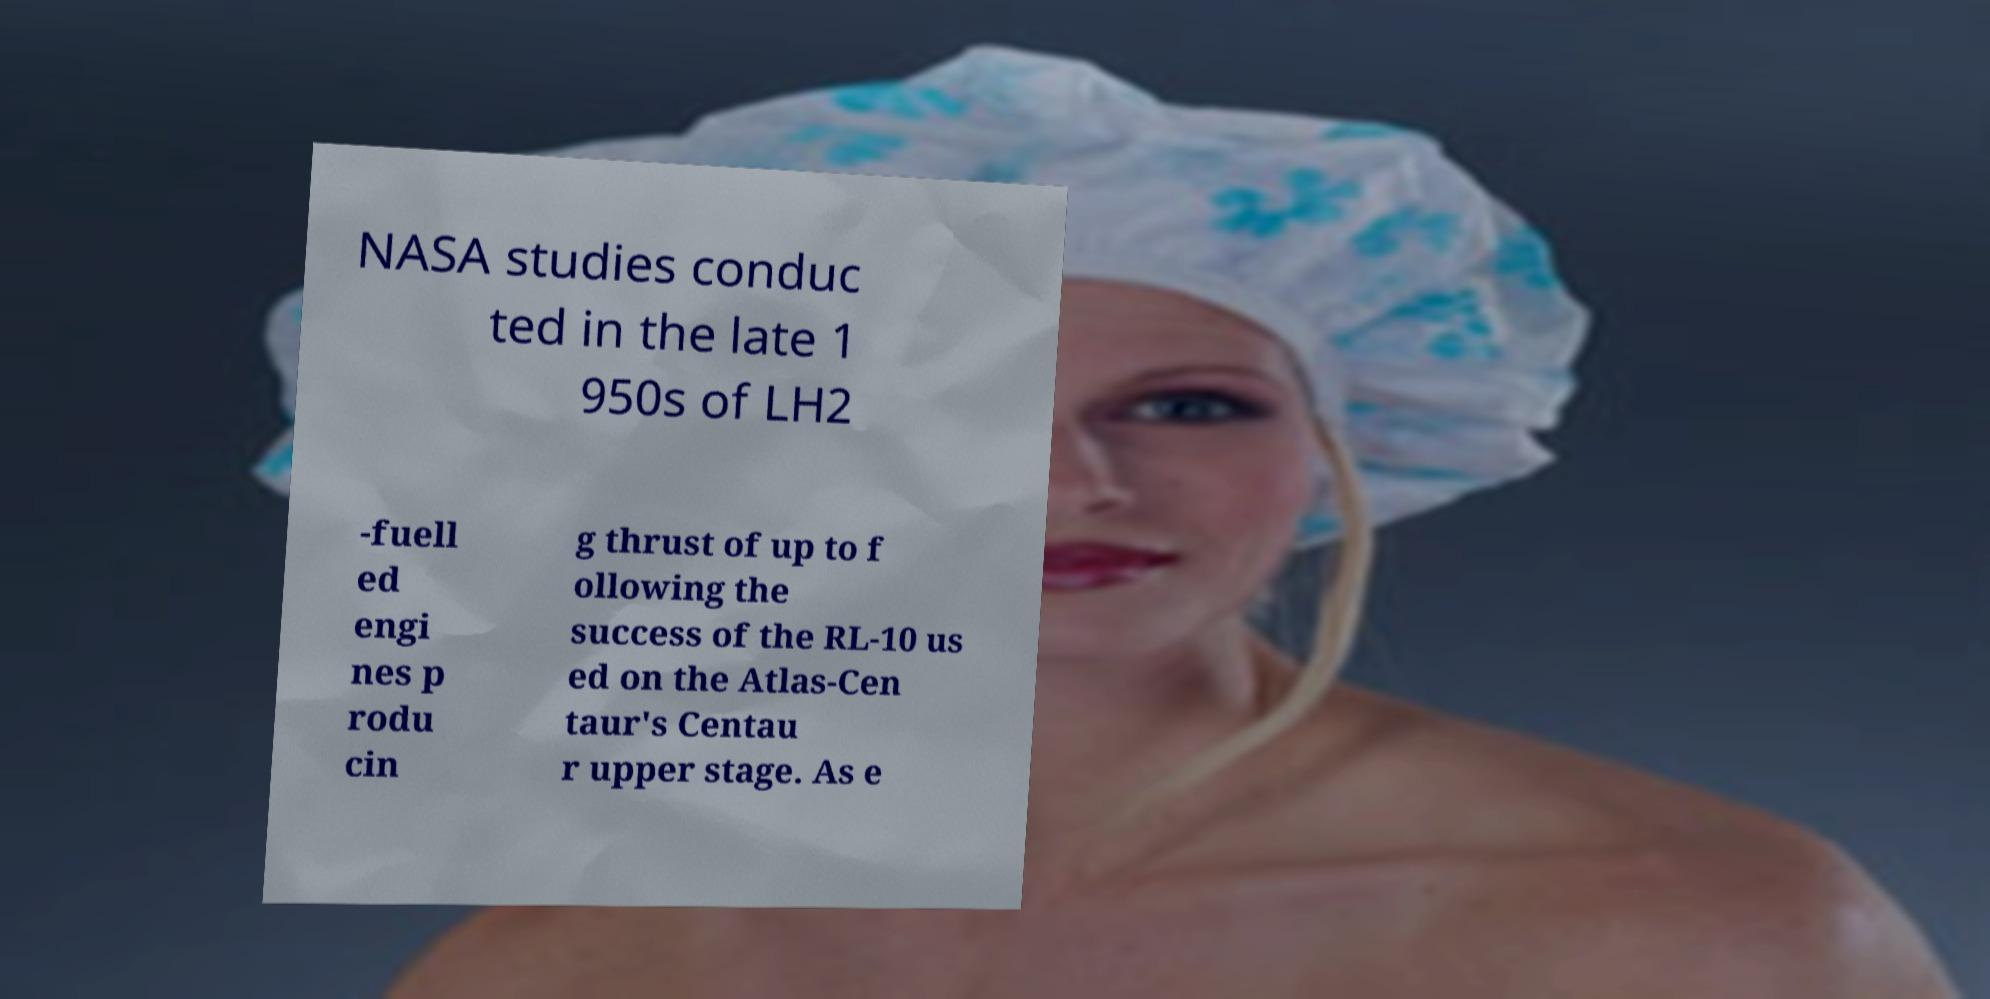For documentation purposes, I need the text within this image transcribed. Could you provide that? NASA studies conduc ted in the late 1 950s of LH2 -fuell ed engi nes p rodu cin g thrust of up to f ollowing the success of the RL-10 us ed on the Atlas-Cen taur's Centau r upper stage. As e 